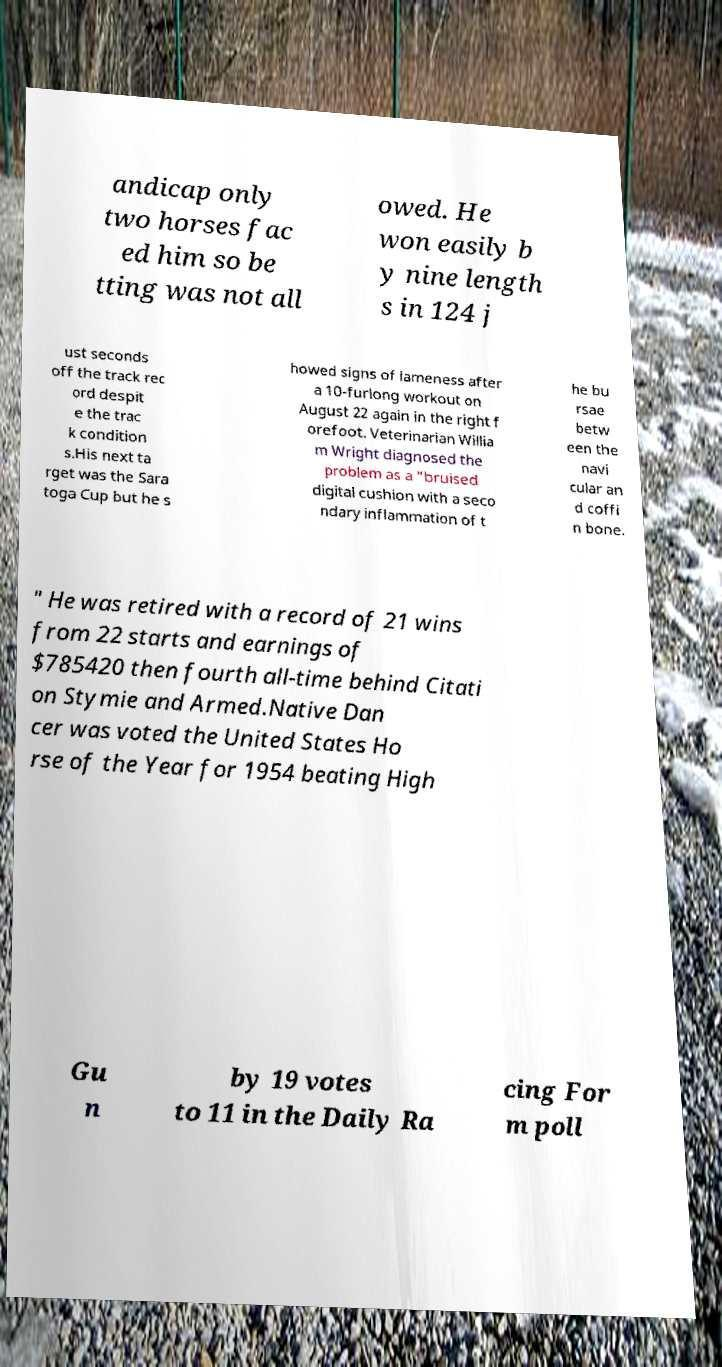Can you read and provide the text displayed in the image?This photo seems to have some interesting text. Can you extract and type it out for me? andicap only two horses fac ed him so be tting was not all owed. He won easily b y nine length s in 124 j ust seconds off the track rec ord despit e the trac k condition s.His next ta rget was the Sara toga Cup but he s howed signs of lameness after a 10-furlong workout on August 22 again in the right f orefoot. Veterinarian Willia m Wright diagnosed the problem as a "bruised digital cushion with a seco ndary inflammation of t he bu rsae betw een the navi cular an d coffi n bone. " He was retired with a record of 21 wins from 22 starts and earnings of $785420 then fourth all-time behind Citati on Stymie and Armed.Native Dan cer was voted the United States Ho rse of the Year for 1954 beating High Gu n by 19 votes to 11 in the Daily Ra cing For m poll 